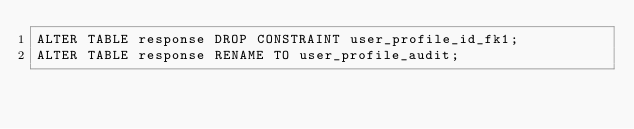<code> <loc_0><loc_0><loc_500><loc_500><_SQL_>ALTER TABLE response DROP CONSTRAINT user_profile_id_fk1;
ALTER TABLE response RENAME TO user_profile_audit;</code> 